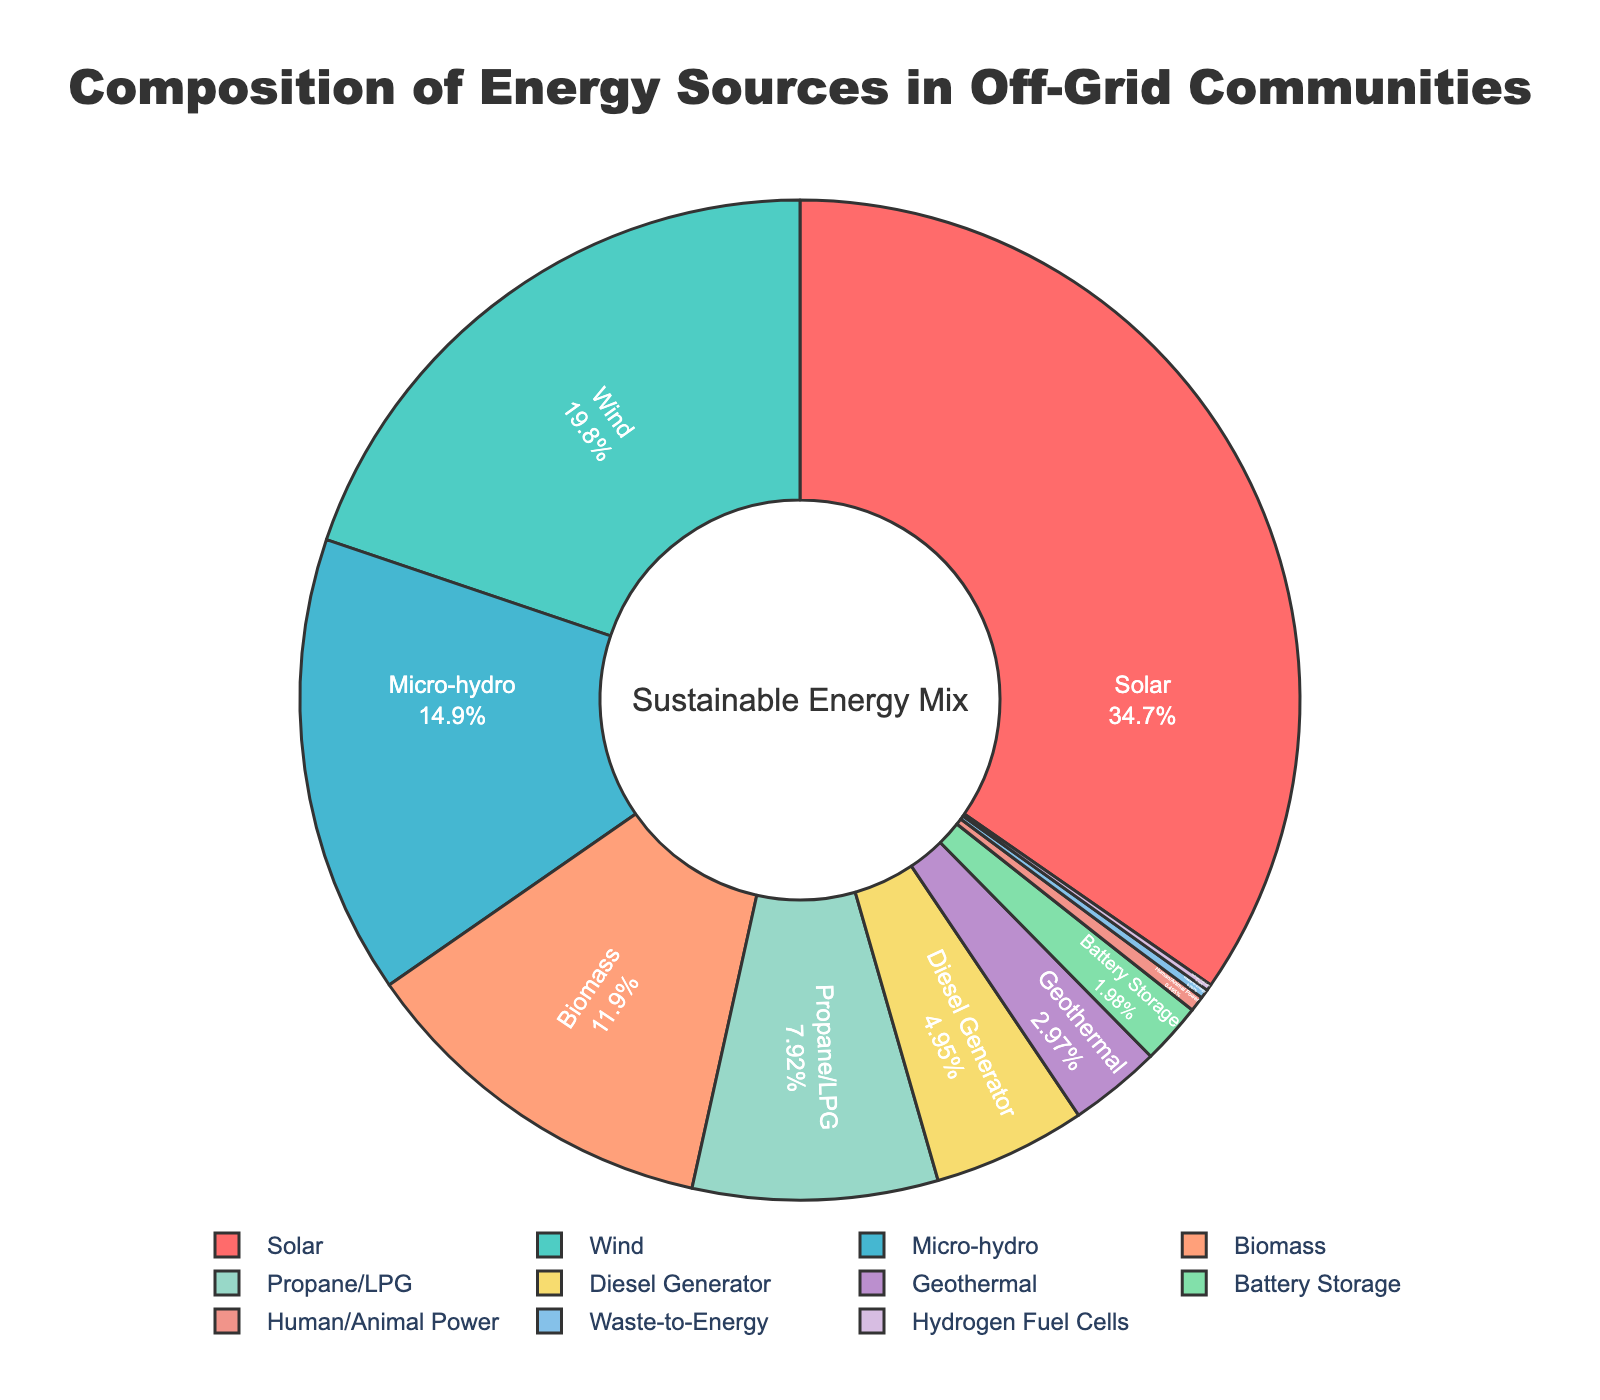What is the combined percentage of energy sourced from biomass and propane/LPG? To find the combined percentage of biomass and propane/LPG, sum their individual percentages: Biomass (12%) + Propane/LPG (8%) = 20%
Answer: 20% Which energy source contributes the second largest part to the energy mix? The energy source with the second largest contribution is Wind at 20%, coming after Solar which is the highest at 35%
Answer: Wind How much more energy does solar contribute compared to diesel generators? Solar contributes 35% and diesel generators contribute 5%, so the difference is 35% - 5% = 30%
Answer: 30% What percentage of energy comes from sources that contribute less than 10% each? Sum the percentages of all sources contributing less than 10%: Propane/LPG (8%) + Diesel Generator (5%) + Geothermal (3%) + Battery Storage (2%) + Human/Animal Power (0.5%) + Waste-to-Energy (0.3%) + Hydrogen Fuel Cells (0.2%) = 19%
Answer: 19% Which energy sources are represented by the green and yellow colors in the chart? Identify the green and yellow colors on the pie chart. Green represents Micro-hydro (15%), and yellow represents Biomass (12%)
Answer: Micro-hydro and Biomass How much less does battery storage contribute compared to biomass? Biomass contributes 12% and battery storage contributes 2%, so the difference is 12% - 2% = 10%
Answer: 10% What is the total percentage of energy sourced from renewable sources (solar, wind, micro-hydro, geothermal)? Sum the percentages of renewable sources: Solar (35%) + Wind (20%) + Micro-hydro (15%) + Geothermal (3%) = 73%
Answer: 73% Describe the proportion of energy sources generating less than 1% each Calculate the proportion by adding percentages of these sources: Human/Animal Power (0.5%) + Waste-to-Energy (0.3%) + Hydrogen Fuel Cells (0.2%) = 1%
Answer: 1% In terms of percentage, how does the use of wind energy compare to that of biomass and propane/LPG combined? Compare Wind's percentage (20%) to the combined percentage of Biomass and Propane/LPG (12% + 8% = 20%): Wind (20%) is equal to the combined (20%)
Answer: Equal What is the name of the annotation displayed at the center of the pie chart? The name of the annotation decorating the center of the chart is "Sustainable Energy Mix"
Answer: Sustainable Energy Mix 